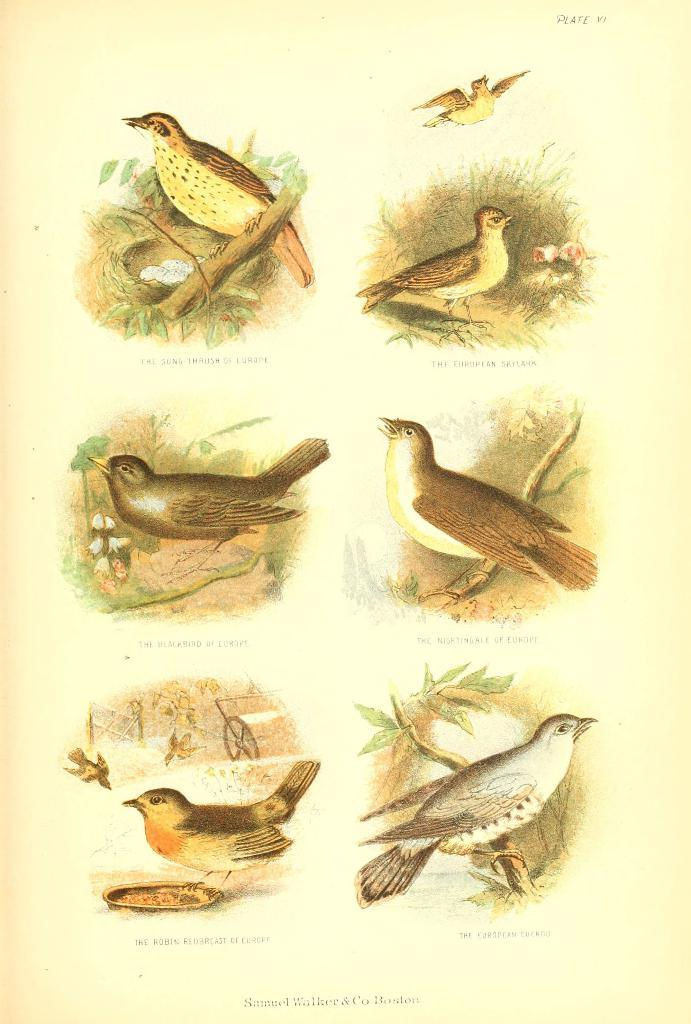What types of animals can be seen in the image? There are different types of birds depicted in the image. What can be found inside the nest in the image? There is a nest with eggs in the image. What is written on the paper in the image? There are letters on the paper. Can you describe the pleasure experienced by the birds in the image? There is no indication of pleasure experienced by the birds in the image. How many times do the birds kiss each other in the image? There is no kissing behavior depicted among the birds in the image. 